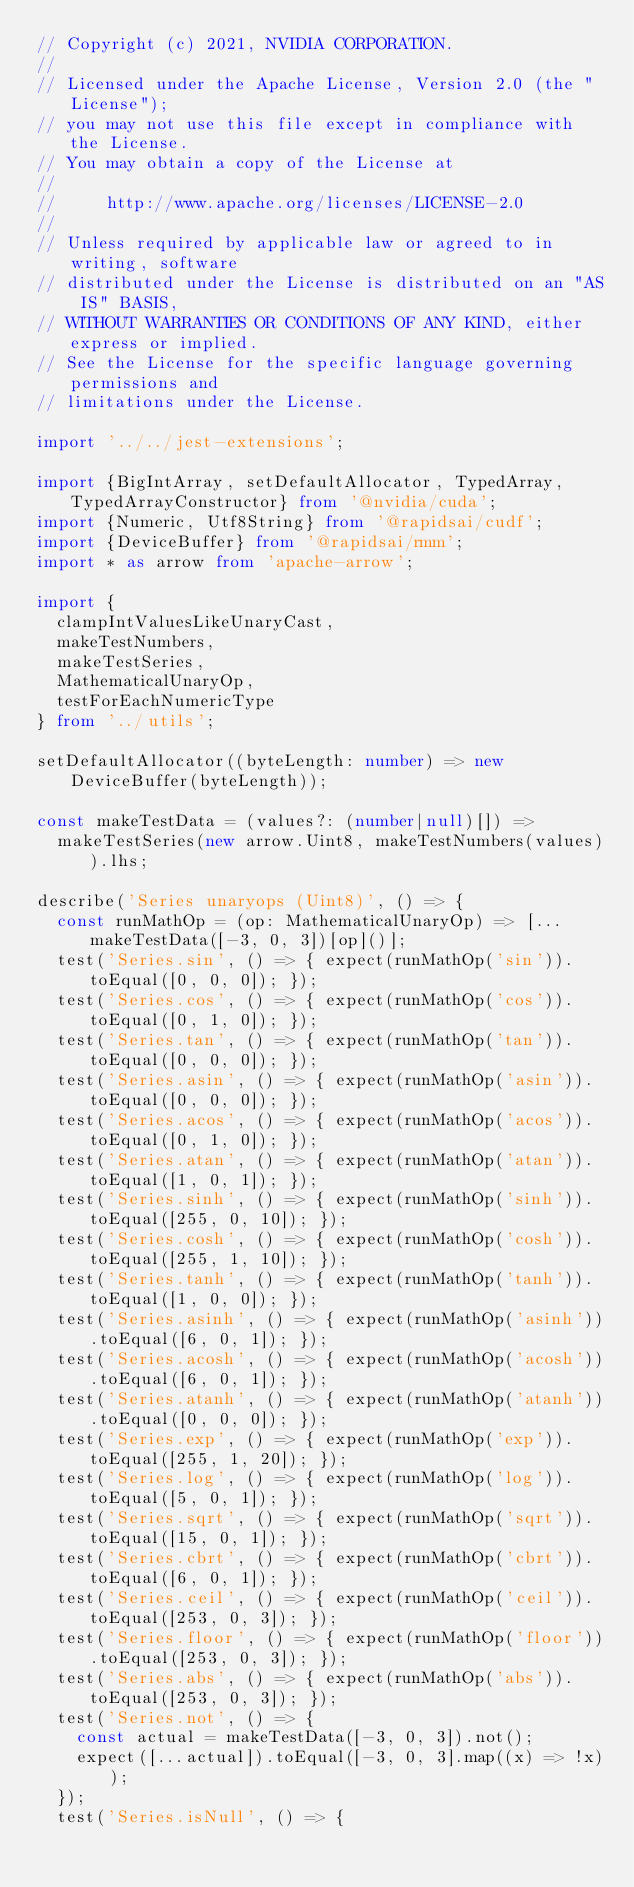<code> <loc_0><loc_0><loc_500><loc_500><_TypeScript_>// Copyright (c) 2021, NVIDIA CORPORATION.
//
// Licensed under the Apache License, Version 2.0 (the "License");
// you may not use this file except in compliance with the License.
// You may obtain a copy of the License at
//
//     http://www.apache.org/licenses/LICENSE-2.0
//
// Unless required by applicable law or agreed to in writing, software
// distributed under the License is distributed on an "AS IS" BASIS,
// WITHOUT WARRANTIES OR CONDITIONS OF ANY KIND, either express or implied.
// See the License for the specific language governing permissions and
// limitations under the License.

import '../../jest-extensions';

import {BigIntArray, setDefaultAllocator, TypedArray, TypedArrayConstructor} from '@nvidia/cuda';
import {Numeric, Utf8String} from '@rapidsai/cudf';
import {DeviceBuffer} from '@rapidsai/rmm';
import * as arrow from 'apache-arrow';

import {
  clampIntValuesLikeUnaryCast,
  makeTestNumbers,
  makeTestSeries,
  MathematicalUnaryOp,
  testForEachNumericType
} from '../utils';

setDefaultAllocator((byteLength: number) => new DeviceBuffer(byteLength));

const makeTestData = (values?: (number|null)[]) =>
  makeTestSeries(new arrow.Uint8, makeTestNumbers(values)).lhs;

describe('Series unaryops (Uint8)', () => {
  const runMathOp = (op: MathematicalUnaryOp) => [...makeTestData([-3, 0, 3])[op]()];
  test('Series.sin', () => { expect(runMathOp('sin')).toEqual([0, 0, 0]); });
  test('Series.cos', () => { expect(runMathOp('cos')).toEqual([0, 1, 0]); });
  test('Series.tan', () => { expect(runMathOp('tan')).toEqual([0, 0, 0]); });
  test('Series.asin', () => { expect(runMathOp('asin')).toEqual([0, 0, 0]); });
  test('Series.acos', () => { expect(runMathOp('acos')).toEqual([0, 1, 0]); });
  test('Series.atan', () => { expect(runMathOp('atan')).toEqual([1, 0, 1]); });
  test('Series.sinh', () => { expect(runMathOp('sinh')).toEqual([255, 0, 10]); });
  test('Series.cosh', () => { expect(runMathOp('cosh')).toEqual([255, 1, 10]); });
  test('Series.tanh', () => { expect(runMathOp('tanh')).toEqual([1, 0, 0]); });
  test('Series.asinh', () => { expect(runMathOp('asinh')).toEqual([6, 0, 1]); });
  test('Series.acosh', () => { expect(runMathOp('acosh')).toEqual([6, 0, 1]); });
  test('Series.atanh', () => { expect(runMathOp('atanh')).toEqual([0, 0, 0]); });
  test('Series.exp', () => { expect(runMathOp('exp')).toEqual([255, 1, 20]); });
  test('Series.log', () => { expect(runMathOp('log')).toEqual([5, 0, 1]); });
  test('Series.sqrt', () => { expect(runMathOp('sqrt')).toEqual([15, 0, 1]); });
  test('Series.cbrt', () => { expect(runMathOp('cbrt')).toEqual([6, 0, 1]); });
  test('Series.ceil', () => { expect(runMathOp('ceil')).toEqual([253, 0, 3]); });
  test('Series.floor', () => { expect(runMathOp('floor')).toEqual([253, 0, 3]); });
  test('Series.abs', () => { expect(runMathOp('abs')).toEqual([253, 0, 3]); });
  test('Series.not', () => {
    const actual = makeTestData([-3, 0, 3]).not();
    expect([...actual]).toEqual([-3, 0, 3].map((x) => !x));
  });
  test('Series.isNull', () => {</code> 